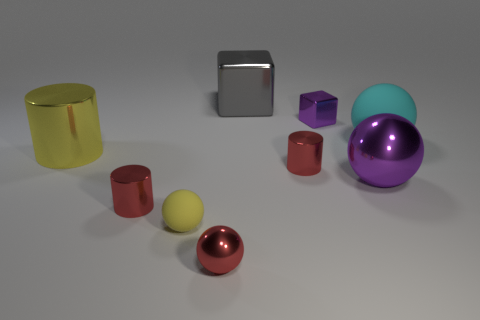Does the big metallic sphere have the same color as the small block?
Your answer should be very brief. Yes. How many small purple blocks have the same material as the red sphere?
Your answer should be very brief. 1. What is the color of the large cylinder that is made of the same material as the tiny red sphere?
Your response must be concise. Yellow. The large yellow object is what shape?
Your answer should be very brief. Cylinder. What material is the tiny sphere that is behind the red sphere?
Your response must be concise. Rubber. Is there a metal object that has the same color as the tiny metal block?
Provide a succinct answer. Yes. What is the shape of the gray object that is the same size as the cyan object?
Your answer should be compact. Cube. What color is the matte sphere in front of the large yellow cylinder?
Ensure brevity in your answer.  Yellow. Is there a small purple cube that is in front of the red metallic object on the right side of the big gray cube?
Provide a succinct answer. No. What number of objects are tiny red things that are in front of the big purple metal object or small cylinders?
Your answer should be compact. 3. 